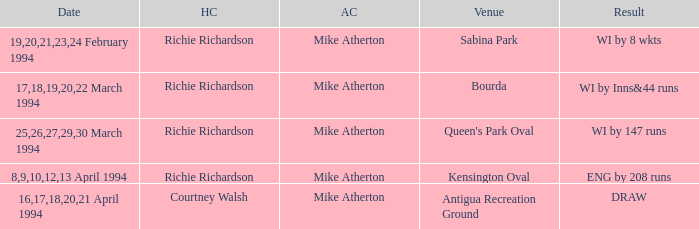What is the result of Courtney Walsh ? DRAW. 